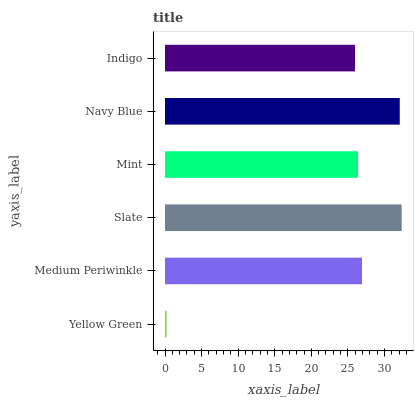Is Yellow Green the minimum?
Answer yes or no. Yes. Is Slate the maximum?
Answer yes or no. Yes. Is Medium Periwinkle the minimum?
Answer yes or no. No. Is Medium Periwinkle the maximum?
Answer yes or no. No. Is Medium Periwinkle greater than Yellow Green?
Answer yes or no. Yes. Is Yellow Green less than Medium Periwinkle?
Answer yes or no. Yes. Is Yellow Green greater than Medium Periwinkle?
Answer yes or no. No. Is Medium Periwinkle less than Yellow Green?
Answer yes or no. No. Is Medium Periwinkle the high median?
Answer yes or no. Yes. Is Mint the low median?
Answer yes or no. Yes. Is Slate the high median?
Answer yes or no. No. Is Medium Periwinkle the low median?
Answer yes or no. No. 